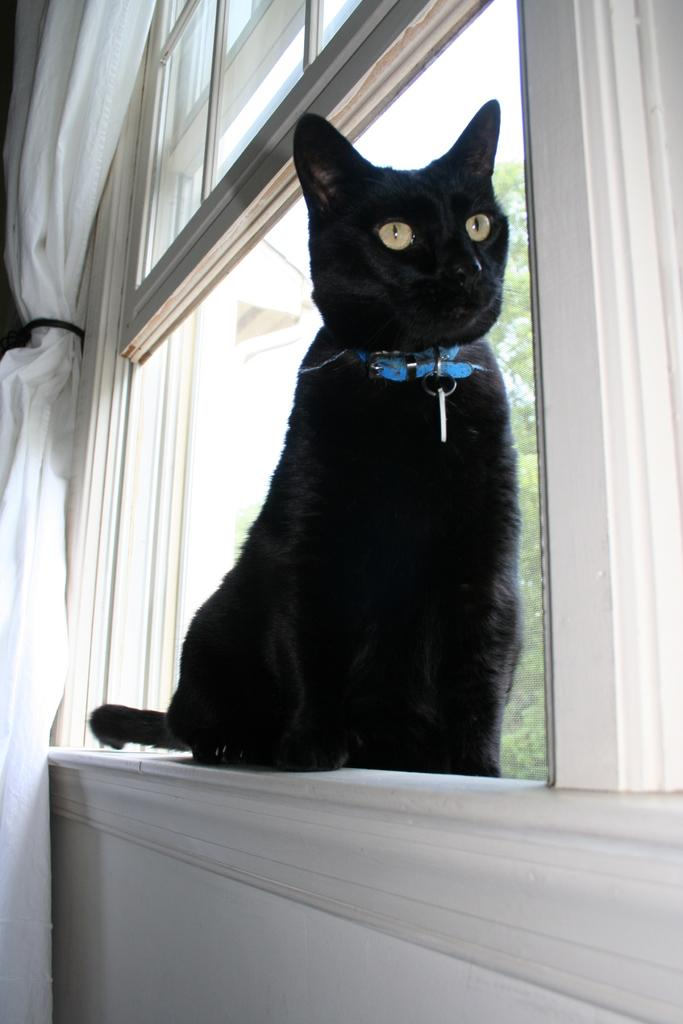What animal is in the foreground of the picture? There is a black cat in the foreground of the picture. Where is the cat located in relation to the window? The cat is sitting near a window. What can be seen in the background of the picture? There is a window in the background of the picture. What is associated with the window? There is a curtain associated with the window. What is visible through the window? A tree is visible through the window. What type of butter is being used by the man in the image? There is no man or butter present in the image; it features a black cat sitting near a window. 